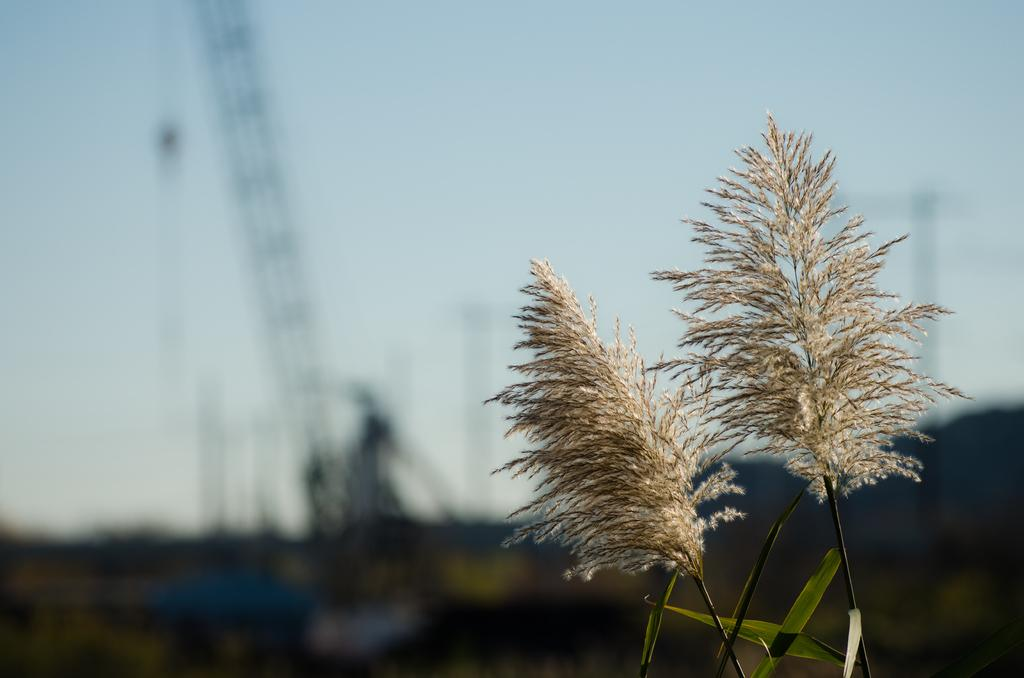What type of vegetation is on the right side of the image? There are flowers of grass on the right side of the image. What is visible at the top of the image? The sky is visible at the top of the image. What type of pancake is being served to the group of people in the image? There is no pancake or group of people present in the image. Who is the owner of the flowers in the image? The image does not provide information about the ownership of the flowers, so it cannot be determined from the image. 